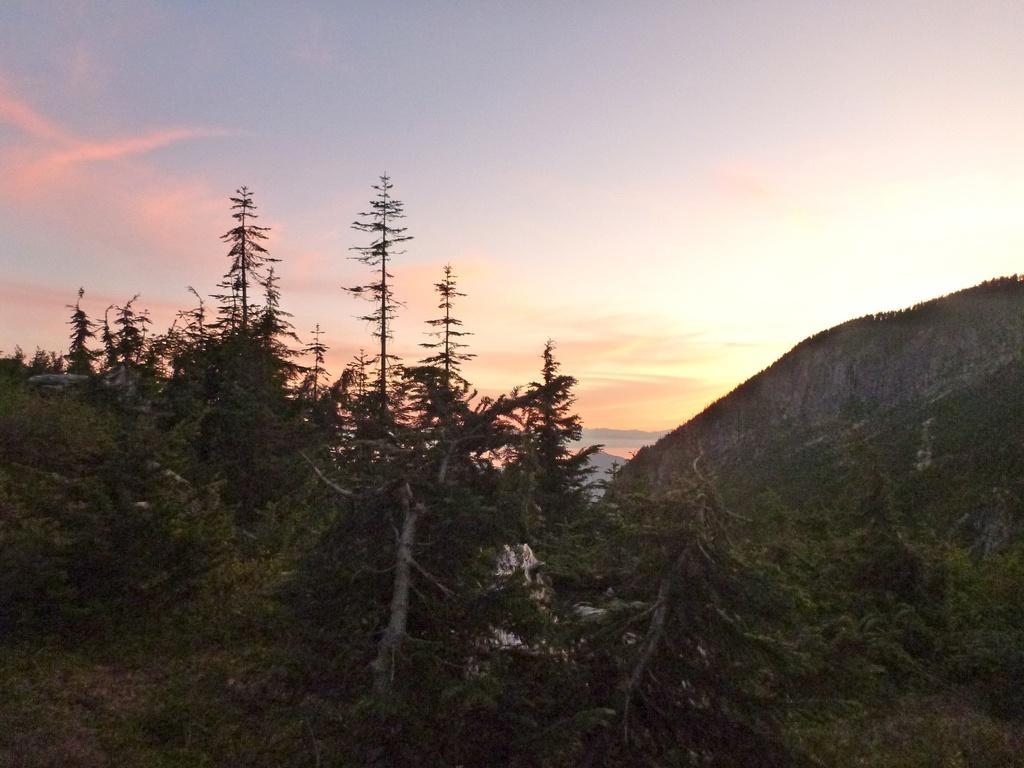Can you describe this image briefly? In this image I can see few trees and mountain. The sky is in white, blue and orange color. 